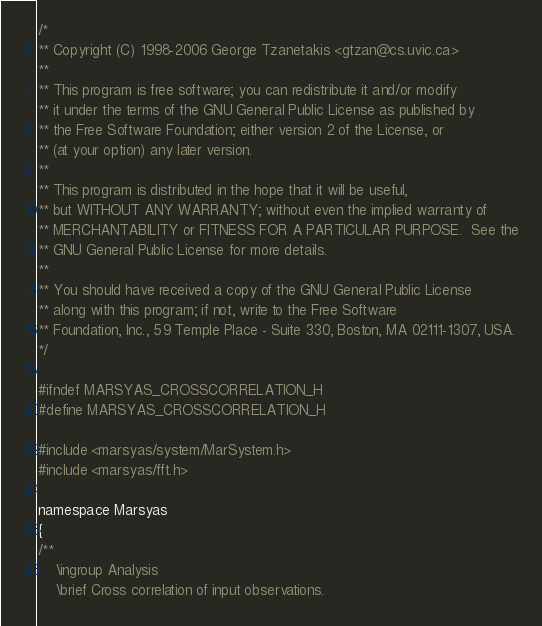Convert code to text. <code><loc_0><loc_0><loc_500><loc_500><_C_>/*
** Copyright (C) 1998-2006 George Tzanetakis <gtzan@cs.uvic.ca>
**
** This program is free software; you can redistribute it and/or modify
** it under the terms of the GNU General Public License as published by
** the Free Software Foundation; either version 2 of the License, or
** (at your option) any later version.
**
** This program is distributed in the hope that it will be useful,
** but WITHOUT ANY WARRANTY; without even the implied warranty of
** MERCHANTABILITY or FITNESS FOR A PARTICULAR PURPOSE.  See the
** GNU General Public License for more details.
**
** You should have received a copy of the GNU General Public License
** along with this program; if not, write to the Free Software
** Foundation, Inc., 59 Temple Place - Suite 330, Boston, MA 02111-1307, USA.
*/

#ifndef MARSYAS_CROSSCORRELATION_H
#define MARSYAS_CROSSCORRELATION_H

#include <marsyas/system/MarSystem.h>
#include <marsyas/fft.h>

namespace Marsyas
{
/**
	\ingroup Analysis
	\brief Cross correlation of input observations.
</code> 